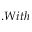<formula> <loc_0><loc_0><loc_500><loc_500>. W i t h</formula> 